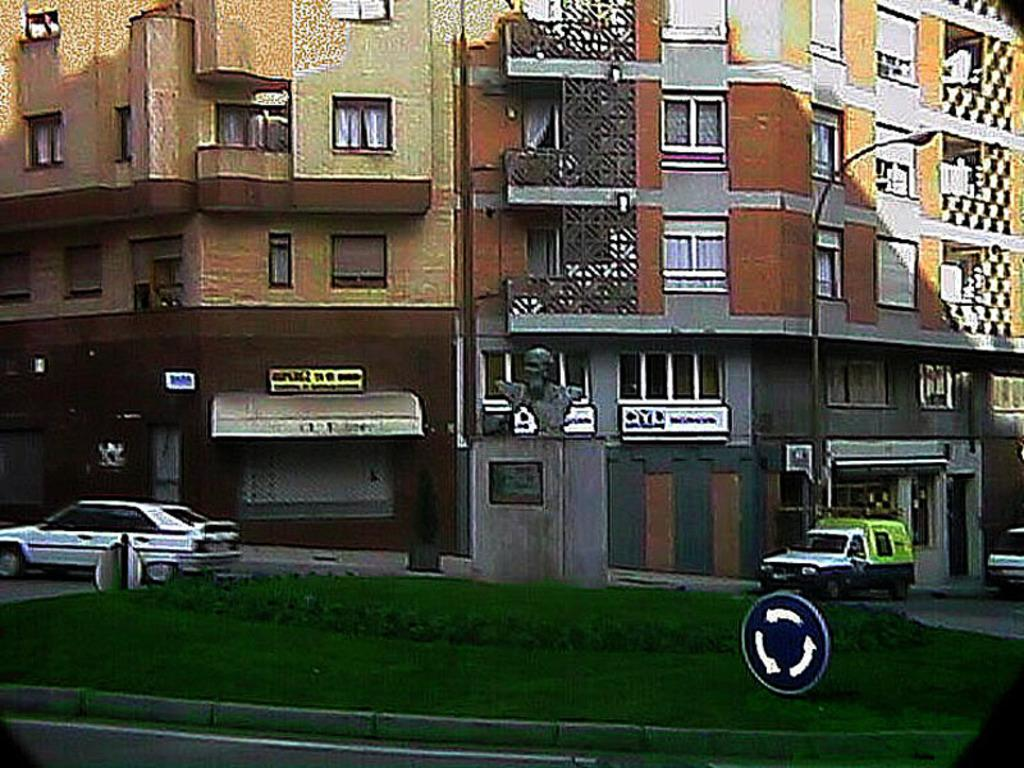What type of structures can be seen in the image? There are buildings in the image. What is happening in front of the buildings? Vehicles are moving in front of the buildings. What artistic element is present in the image? There is a sculpture in the image. What type of vegetation is visible in the image? Grass is visible in the image. What language is the crayon speaking in the image? There is no crayon present in the image, and therefore it cannot be speaking any language. 